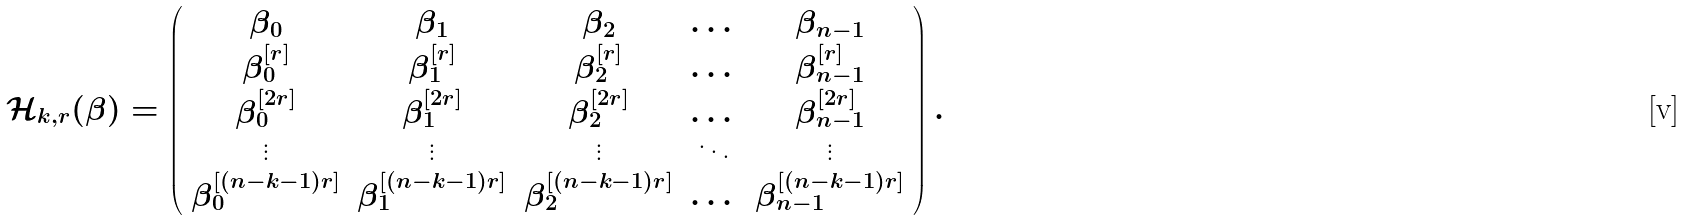Convert formula to latex. <formula><loc_0><loc_0><loc_500><loc_500>\mathcal { H } _ { k , r } ( \boldsymbol \beta ) = \left ( \begin{array} { c c c c c } \beta _ { 0 } & \beta _ { 1 } & \beta _ { 2 } & \dots & \beta _ { n - 1 } \\ \beta _ { 0 } ^ { [ r ] } & \beta _ { 1 } ^ { [ r ] } & \beta _ { 2 } ^ { [ r ] } & \dots & \beta _ { n - 1 } ^ { [ r ] } \\ \beta _ { 0 } ^ { [ 2 r ] } & \beta _ { 1 } ^ { [ 2 r ] } & \beta _ { 2 } ^ { [ 2 r ] } & \dots & \beta _ { n - 1 } ^ { [ 2 r ] } \\ \vdots & \vdots & \vdots & \ddots & \vdots \\ \beta _ { 0 } ^ { [ ( n - k - 1 ) r ] } & \beta _ { 1 } ^ { [ ( n - k - 1 ) r ] } & \beta _ { 2 } ^ { [ ( n - k - 1 ) r ] } & \dots & \beta _ { n - 1 } ^ { [ ( n - k - 1 ) r ] } \\ \end{array} \right ) .</formula> 